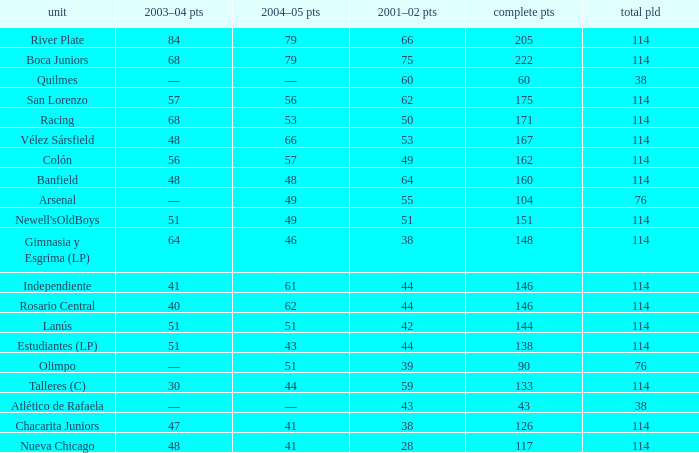Which Team has a Total Pld smaller than 114, and a 2004–05 Pts of 49? Arsenal. 